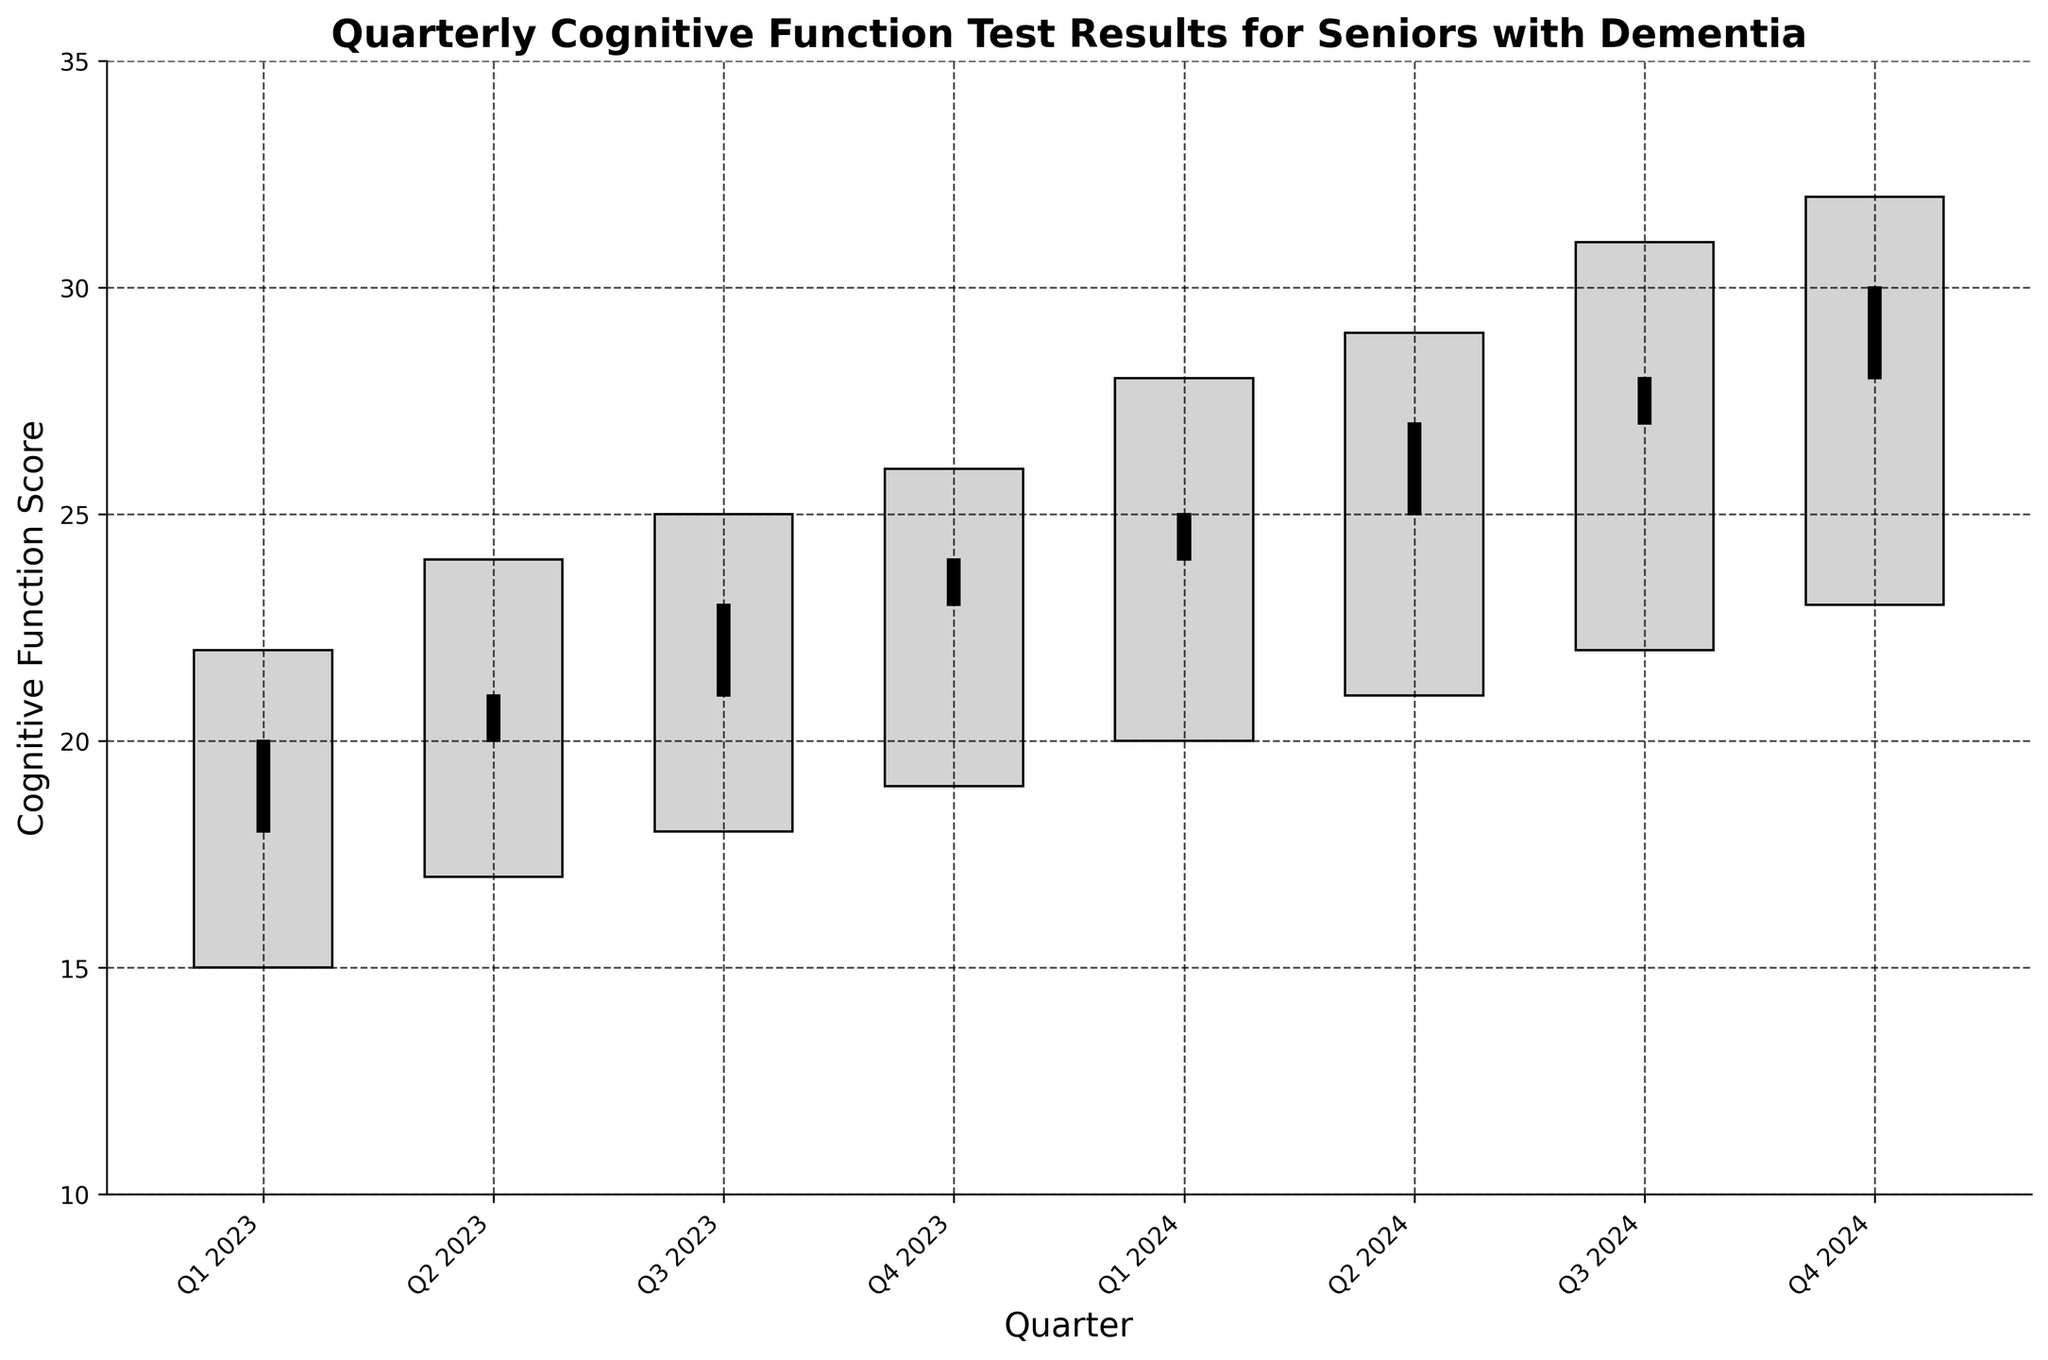Which quarter had the highest high value of cognitive function score? The highest high value among all the quarters is the tallest bar segment. By examining the highs, Q4 2024 has the highest high value of 32.
Answer: Q4 2024 Which quarter had the biggest range between the high and low values? To find the biggest range, subtract the low value from the high value for each quarter and compare them. The range is largest in Q3 2024 with a difference of 9 (31 - 22).
Answer: Q3 2024 What is the pattern observed in the closing values over the quarters? Observing the graph, the closing values of the cognitive function score increase sequentially from Q1 2023 to Q4 2024, demonstrating an upward trend.
Answer: Increasing trend Compare the cognitive function scores for Q1 2023 and Q1 2024. What can you infer? In Q1 2023, the close value was 20, and in Q1 2024, the close value was 25. This indicates an improvement in the cognitive function scores over one year.
Answer: Improvement Which quarter had the smallest change between the open and close values? The smallest change between the open and close values can be found by finding the absolute difference for each quarter. The smallest change is observed in Q2 2023 with a difference of 1 (21 - 20).
Answer: Q2 2023 How did the cognitive function score open and close values change from Q2 2024 to Q4 2024? From Q2 2024 (open 25, close 27) to Q4 2024 (open 28, close 30), both the open and close values increased.
Answer: Increased What is the average close value for 2024? The close values for 2024 are 25, 27, 28, and 30. Summing these gives 110, and dividing by 4 (the number of quarters) gives 27.5.
Answer: 27.5 Which quarter shows the highest increase from open to close value? The highest increase is identified by examining the difference between the open and close values. The greatest increase is 2 in Q2 2024 (from 25 to 27; 27-25).
Answer: Q2 2024 What can be inferred about the seniors' cognitive function trend from Q1 2023 to Q4 2024? By observing the overall upward trend in close values and highs, it can be inferred that there is an overall improvement in the seniors' cognitive function over this period.
Answer: Overall improvement 